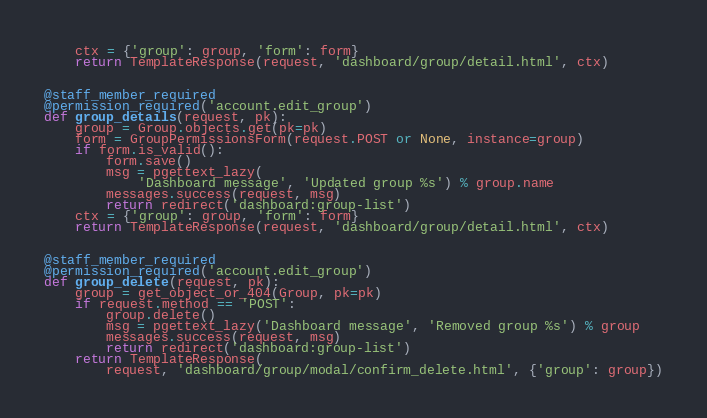<code> <loc_0><loc_0><loc_500><loc_500><_Python_>    ctx = {'group': group, 'form': form}
    return TemplateResponse(request, 'dashboard/group/detail.html', ctx)


@staff_member_required
@permission_required('account.edit_group')
def group_details(request, pk):
    group = Group.objects.get(pk=pk)
    form = GroupPermissionsForm(request.POST or None, instance=group)
    if form.is_valid():
        form.save()
        msg = pgettext_lazy(
            'Dashboard message', 'Updated group %s') % group.name
        messages.success(request, msg)
        return redirect('dashboard:group-list')
    ctx = {'group': group, 'form': form}
    return TemplateResponse(request, 'dashboard/group/detail.html', ctx)


@staff_member_required
@permission_required('account.edit_group')
def group_delete(request, pk):
    group = get_object_or_404(Group, pk=pk)
    if request.method == 'POST':
        group.delete()
        msg = pgettext_lazy('Dashboard message', 'Removed group %s') % group
        messages.success(request, msg)
        return redirect('dashboard:group-list')
    return TemplateResponse(
        request, 'dashboard/group/modal/confirm_delete.html', {'group': group})
</code> 